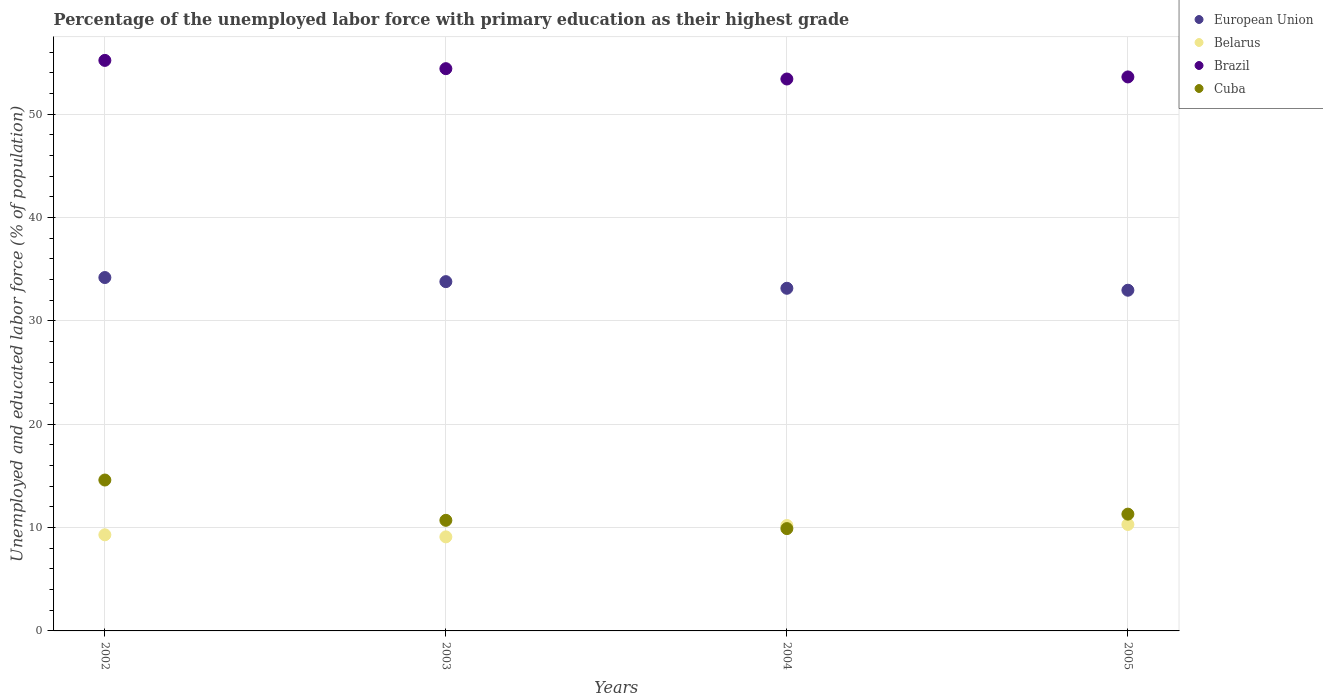What is the percentage of the unemployed labor force with primary education in Brazil in 2004?
Give a very brief answer. 53.4. Across all years, what is the maximum percentage of the unemployed labor force with primary education in Belarus?
Offer a terse response. 10.3. Across all years, what is the minimum percentage of the unemployed labor force with primary education in Belarus?
Make the answer very short. 9.1. In which year was the percentage of the unemployed labor force with primary education in European Union maximum?
Keep it short and to the point. 2002. What is the total percentage of the unemployed labor force with primary education in Cuba in the graph?
Provide a succinct answer. 46.5. What is the difference between the percentage of the unemployed labor force with primary education in European Union in 2002 and that in 2003?
Your response must be concise. 0.4. What is the difference between the percentage of the unemployed labor force with primary education in Belarus in 2002 and the percentage of the unemployed labor force with primary education in European Union in 2005?
Keep it short and to the point. -23.66. What is the average percentage of the unemployed labor force with primary education in Brazil per year?
Your answer should be very brief. 54.15. In the year 2005, what is the difference between the percentage of the unemployed labor force with primary education in Brazil and percentage of the unemployed labor force with primary education in Cuba?
Your response must be concise. 42.3. What is the ratio of the percentage of the unemployed labor force with primary education in Brazil in 2002 to that in 2004?
Provide a short and direct response. 1.03. Is the difference between the percentage of the unemployed labor force with primary education in Brazil in 2003 and 2004 greater than the difference between the percentage of the unemployed labor force with primary education in Cuba in 2003 and 2004?
Offer a very short reply. Yes. What is the difference between the highest and the second highest percentage of the unemployed labor force with primary education in Brazil?
Provide a succinct answer. 0.8. What is the difference between the highest and the lowest percentage of the unemployed labor force with primary education in Cuba?
Your answer should be compact. 4.7. Is the sum of the percentage of the unemployed labor force with primary education in Cuba in 2002 and 2005 greater than the maximum percentage of the unemployed labor force with primary education in Belarus across all years?
Provide a succinct answer. Yes. Is it the case that in every year, the sum of the percentage of the unemployed labor force with primary education in European Union and percentage of the unemployed labor force with primary education in Belarus  is greater than the percentage of the unemployed labor force with primary education in Cuba?
Provide a succinct answer. Yes. Is the percentage of the unemployed labor force with primary education in Belarus strictly greater than the percentage of the unemployed labor force with primary education in Brazil over the years?
Make the answer very short. No. How many years are there in the graph?
Ensure brevity in your answer.  4. What is the difference between two consecutive major ticks on the Y-axis?
Offer a very short reply. 10. How many legend labels are there?
Offer a terse response. 4. What is the title of the graph?
Provide a short and direct response. Percentage of the unemployed labor force with primary education as their highest grade. Does "Panama" appear as one of the legend labels in the graph?
Provide a short and direct response. No. What is the label or title of the X-axis?
Your answer should be very brief. Years. What is the label or title of the Y-axis?
Ensure brevity in your answer.  Unemployed and educated labor force (% of population). What is the Unemployed and educated labor force (% of population) of European Union in 2002?
Ensure brevity in your answer.  34.19. What is the Unemployed and educated labor force (% of population) in Belarus in 2002?
Provide a succinct answer. 9.3. What is the Unemployed and educated labor force (% of population) of Brazil in 2002?
Provide a short and direct response. 55.2. What is the Unemployed and educated labor force (% of population) in Cuba in 2002?
Give a very brief answer. 14.6. What is the Unemployed and educated labor force (% of population) in European Union in 2003?
Your answer should be very brief. 33.79. What is the Unemployed and educated labor force (% of population) in Belarus in 2003?
Your answer should be very brief. 9.1. What is the Unemployed and educated labor force (% of population) in Brazil in 2003?
Your response must be concise. 54.4. What is the Unemployed and educated labor force (% of population) in Cuba in 2003?
Offer a very short reply. 10.7. What is the Unemployed and educated labor force (% of population) in European Union in 2004?
Provide a short and direct response. 33.15. What is the Unemployed and educated labor force (% of population) of Belarus in 2004?
Make the answer very short. 10.2. What is the Unemployed and educated labor force (% of population) of Brazil in 2004?
Ensure brevity in your answer.  53.4. What is the Unemployed and educated labor force (% of population) in Cuba in 2004?
Make the answer very short. 9.9. What is the Unemployed and educated labor force (% of population) of European Union in 2005?
Give a very brief answer. 32.96. What is the Unemployed and educated labor force (% of population) in Belarus in 2005?
Your answer should be very brief. 10.3. What is the Unemployed and educated labor force (% of population) of Brazil in 2005?
Ensure brevity in your answer.  53.6. What is the Unemployed and educated labor force (% of population) of Cuba in 2005?
Offer a terse response. 11.3. Across all years, what is the maximum Unemployed and educated labor force (% of population) in European Union?
Your answer should be very brief. 34.19. Across all years, what is the maximum Unemployed and educated labor force (% of population) in Belarus?
Offer a very short reply. 10.3. Across all years, what is the maximum Unemployed and educated labor force (% of population) in Brazil?
Your answer should be compact. 55.2. Across all years, what is the maximum Unemployed and educated labor force (% of population) of Cuba?
Ensure brevity in your answer.  14.6. Across all years, what is the minimum Unemployed and educated labor force (% of population) of European Union?
Your answer should be very brief. 32.96. Across all years, what is the minimum Unemployed and educated labor force (% of population) of Belarus?
Your response must be concise. 9.1. Across all years, what is the minimum Unemployed and educated labor force (% of population) in Brazil?
Your response must be concise. 53.4. Across all years, what is the minimum Unemployed and educated labor force (% of population) of Cuba?
Keep it short and to the point. 9.9. What is the total Unemployed and educated labor force (% of population) of European Union in the graph?
Your answer should be compact. 134.1. What is the total Unemployed and educated labor force (% of population) of Belarus in the graph?
Keep it short and to the point. 38.9. What is the total Unemployed and educated labor force (% of population) in Brazil in the graph?
Keep it short and to the point. 216.6. What is the total Unemployed and educated labor force (% of population) of Cuba in the graph?
Provide a short and direct response. 46.5. What is the difference between the Unemployed and educated labor force (% of population) in European Union in 2002 and that in 2003?
Provide a short and direct response. 0.4. What is the difference between the Unemployed and educated labor force (% of population) of Brazil in 2002 and that in 2003?
Provide a succinct answer. 0.8. What is the difference between the Unemployed and educated labor force (% of population) in Cuba in 2002 and that in 2003?
Give a very brief answer. 3.9. What is the difference between the Unemployed and educated labor force (% of population) in European Union in 2002 and that in 2004?
Offer a very short reply. 1.04. What is the difference between the Unemployed and educated labor force (% of population) of Cuba in 2002 and that in 2004?
Give a very brief answer. 4.7. What is the difference between the Unemployed and educated labor force (% of population) in European Union in 2002 and that in 2005?
Provide a short and direct response. 1.23. What is the difference between the Unemployed and educated labor force (% of population) in Brazil in 2002 and that in 2005?
Offer a very short reply. 1.6. What is the difference between the Unemployed and educated labor force (% of population) of European Union in 2003 and that in 2004?
Give a very brief answer. 0.64. What is the difference between the Unemployed and educated labor force (% of population) in Belarus in 2003 and that in 2004?
Ensure brevity in your answer.  -1.1. What is the difference between the Unemployed and educated labor force (% of population) of Brazil in 2003 and that in 2004?
Give a very brief answer. 1. What is the difference between the Unemployed and educated labor force (% of population) of Cuba in 2003 and that in 2004?
Your answer should be compact. 0.8. What is the difference between the Unemployed and educated labor force (% of population) in European Union in 2003 and that in 2005?
Offer a very short reply. 0.83. What is the difference between the Unemployed and educated labor force (% of population) in Cuba in 2003 and that in 2005?
Your answer should be very brief. -0.6. What is the difference between the Unemployed and educated labor force (% of population) in European Union in 2004 and that in 2005?
Provide a succinct answer. 0.19. What is the difference between the Unemployed and educated labor force (% of population) in Belarus in 2004 and that in 2005?
Your answer should be very brief. -0.1. What is the difference between the Unemployed and educated labor force (% of population) of Brazil in 2004 and that in 2005?
Your answer should be very brief. -0.2. What is the difference between the Unemployed and educated labor force (% of population) of Cuba in 2004 and that in 2005?
Your answer should be very brief. -1.4. What is the difference between the Unemployed and educated labor force (% of population) of European Union in 2002 and the Unemployed and educated labor force (% of population) of Belarus in 2003?
Offer a terse response. 25.09. What is the difference between the Unemployed and educated labor force (% of population) in European Union in 2002 and the Unemployed and educated labor force (% of population) in Brazil in 2003?
Provide a succinct answer. -20.21. What is the difference between the Unemployed and educated labor force (% of population) of European Union in 2002 and the Unemployed and educated labor force (% of population) of Cuba in 2003?
Your response must be concise. 23.49. What is the difference between the Unemployed and educated labor force (% of population) of Belarus in 2002 and the Unemployed and educated labor force (% of population) of Brazil in 2003?
Your answer should be very brief. -45.1. What is the difference between the Unemployed and educated labor force (% of population) in Belarus in 2002 and the Unemployed and educated labor force (% of population) in Cuba in 2003?
Your answer should be very brief. -1.4. What is the difference between the Unemployed and educated labor force (% of population) of Brazil in 2002 and the Unemployed and educated labor force (% of population) of Cuba in 2003?
Your answer should be very brief. 44.5. What is the difference between the Unemployed and educated labor force (% of population) of European Union in 2002 and the Unemployed and educated labor force (% of population) of Belarus in 2004?
Your answer should be very brief. 23.99. What is the difference between the Unemployed and educated labor force (% of population) in European Union in 2002 and the Unemployed and educated labor force (% of population) in Brazil in 2004?
Ensure brevity in your answer.  -19.21. What is the difference between the Unemployed and educated labor force (% of population) in European Union in 2002 and the Unemployed and educated labor force (% of population) in Cuba in 2004?
Offer a very short reply. 24.29. What is the difference between the Unemployed and educated labor force (% of population) of Belarus in 2002 and the Unemployed and educated labor force (% of population) of Brazil in 2004?
Provide a succinct answer. -44.1. What is the difference between the Unemployed and educated labor force (% of population) of Brazil in 2002 and the Unemployed and educated labor force (% of population) of Cuba in 2004?
Provide a succinct answer. 45.3. What is the difference between the Unemployed and educated labor force (% of population) in European Union in 2002 and the Unemployed and educated labor force (% of population) in Belarus in 2005?
Offer a very short reply. 23.89. What is the difference between the Unemployed and educated labor force (% of population) of European Union in 2002 and the Unemployed and educated labor force (% of population) of Brazil in 2005?
Keep it short and to the point. -19.41. What is the difference between the Unemployed and educated labor force (% of population) in European Union in 2002 and the Unemployed and educated labor force (% of population) in Cuba in 2005?
Your response must be concise. 22.89. What is the difference between the Unemployed and educated labor force (% of population) of Belarus in 2002 and the Unemployed and educated labor force (% of population) of Brazil in 2005?
Provide a succinct answer. -44.3. What is the difference between the Unemployed and educated labor force (% of population) of Brazil in 2002 and the Unemployed and educated labor force (% of population) of Cuba in 2005?
Offer a terse response. 43.9. What is the difference between the Unemployed and educated labor force (% of population) in European Union in 2003 and the Unemployed and educated labor force (% of population) in Belarus in 2004?
Give a very brief answer. 23.59. What is the difference between the Unemployed and educated labor force (% of population) in European Union in 2003 and the Unemployed and educated labor force (% of population) in Brazil in 2004?
Make the answer very short. -19.61. What is the difference between the Unemployed and educated labor force (% of population) of European Union in 2003 and the Unemployed and educated labor force (% of population) of Cuba in 2004?
Make the answer very short. 23.89. What is the difference between the Unemployed and educated labor force (% of population) of Belarus in 2003 and the Unemployed and educated labor force (% of population) of Brazil in 2004?
Give a very brief answer. -44.3. What is the difference between the Unemployed and educated labor force (% of population) of Belarus in 2003 and the Unemployed and educated labor force (% of population) of Cuba in 2004?
Ensure brevity in your answer.  -0.8. What is the difference between the Unemployed and educated labor force (% of population) of Brazil in 2003 and the Unemployed and educated labor force (% of population) of Cuba in 2004?
Your answer should be very brief. 44.5. What is the difference between the Unemployed and educated labor force (% of population) of European Union in 2003 and the Unemployed and educated labor force (% of population) of Belarus in 2005?
Keep it short and to the point. 23.49. What is the difference between the Unemployed and educated labor force (% of population) in European Union in 2003 and the Unemployed and educated labor force (% of population) in Brazil in 2005?
Keep it short and to the point. -19.81. What is the difference between the Unemployed and educated labor force (% of population) of European Union in 2003 and the Unemployed and educated labor force (% of population) of Cuba in 2005?
Offer a very short reply. 22.49. What is the difference between the Unemployed and educated labor force (% of population) in Belarus in 2003 and the Unemployed and educated labor force (% of population) in Brazil in 2005?
Make the answer very short. -44.5. What is the difference between the Unemployed and educated labor force (% of population) in Brazil in 2003 and the Unemployed and educated labor force (% of population) in Cuba in 2005?
Your answer should be compact. 43.1. What is the difference between the Unemployed and educated labor force (% of population) in European Union in 2004 and the Unemployed and educated labor force (% of population) in Belarus in 2005?
Your answer should be compact. 22.85. What is the difference between the Unemployed and educated labor force (% of population) of European Union in 2004 and the Unemployed and educated labor force (% of population) of Brazil in 2005?
Make the answer very short. -20.45. What is the difference between the Unemployed and educated labor force (% of population) of European Union in 2004 and the Unemployed and educated labor force (% of population) of Cuba in 2005?
Provide a succinct answer. 21.85. What is the difference between the Unemployed and educated labor force (% of population) in Belarus in 2004 and the Unemployed and educated labor force (% of population) in Brazil in 2005?
Give a very brief answer. -43.4. What is the difference between the Unemployed and educated labor force (% of population) in Brazil in 2004 and the Unemployed and educated labor force (% of population) in Cuba in 2005?
Keep it short and to the point. 42.1. What is the average Unemployed and educated labor force (% of population) of European Union per year?
Provide a succinct answer. 33.53. What is the average Unemployed and educated labor force (% of population) of Belarus per year?
Keep it short and to the point. 9.72. What is the average Unemployed and educated labor force (% of population) in Brazil per year?
Make the answer very short. 54.15. What is the average Unemployed and educated labor force (% of population) of Cuba per year?
Offer a terse response. 11.62. In the year 2002, what is the difference between the Unemployed and educated labor force (% of population) of European Union and Unemployed and educated labor force (% of population) of Belarus?
Offer a very short reply. 24.89. In the year 2002, what is the difference between the Unemployed and educated labor force (% of population) of European Union and Unemployed and educated labor force (% of population) of Brazil?
Ensure brevity in your answer.  -21.01. In the year 2002, what is the difference between the Unemployed and educated labor force (% of population) of European Union and Unemployed and educated labor force (% of population) of Cuba?
Provide a succinct answer. 19.59. In the year 2002, what is the difference between the Unemployed and educated labor force (% of population) of Belarus and Unemployed and educated labor force (% of population) of Brazil?
Your answer should be very brief. -45.9. In the year 2002, what is the difference between the Unemployed and educated labor force (% of population) of Belarus and Unemployed and educated labor force (% of population) of Cuba?
Offer a terse response. -5.3. In the year 2002, what is the difference between the Unemployed and educated labor force (% of population) in Brazil and Unemployed and educated labor force (% of population) in Cuba?
Offer a very short reply. 40.6. In the year 2003, what is the difference between the Unemployed and educated labor force (% of population) of European Union and Unemployed and educated labor force (% of population) of Belarus?
Make the answer very short. 24.69. In the year 2003, what is the difference between the Unemployed and educated labor force (% of population) in European Union and Unemployed and educated labor force (% of population) in Brazil?
Your answer should be compact. -20.61. In the year 2003, what is the difference between the Unemployed and educated labor force (% of population) in European Union and Unemployed and educated labor force (% of population) in Cuba?
Offer a terse response. 23.09. In the year 2003, what is the difference between the Unemployed and educated labor force (% of population) of Belarus and Unemployed and educated labor force (% of population) of Brazil?
Your answer should be compact. -45.3. In the year 2003, what is the difference between the Unemployed and educated labor force (% of population) in Brazil and Unemployed and educated labor force (% of population) in Cuba?
Give a very brief answer. 43.7. In the year 2004, what is the difference between the Unemployed and educated labor force (% of population) in European Union and Unemployed and educated labor force (% of population) in Belarus?
Make the answer very short. 22.95. In the year 2004, what is the difference between the Unemployed and educated labor force (% of population) of European Union and Unemployed and educated labor force (% of population) of Brazil?
Ensure brevity in your answer.  -20.25. In the year 2004, what is the difference between the Unemployed and educated labor force (% of population) in European Union and Unemployed and educated labor force (% of population) in Cuba?
Ensure brevity in your answer.  23.25. In the year 2004, what is the difference between the Unemployed and educated labor force (% of population) of Belarus and Unemployed and educated labor force (% of population) of Brazil?
Ensure brevity in your answer.  -43.2. In the year 2004, what is the difference between the Unemployed and educated labor force (% of population) of Belarus and Unemployed and educated labor force (% of population) of Cuba?
Keep it short and to the point. 0.3. In the year 2004, what is the difference between the Unemployed and educated labor force (% of population) of Brazil and Unemployed and educated labor force (% of population) of Cuba?
Provide a short and direct response. 43.5. In the year 2005, what is the difference between the Unemployed and educated labor force (% of population) in European Union and Unemployed and educated labor force (% of population) in Belarus?
Provide a short and direct response. 22.66. In the year 2005, what is the difference between the Unemployed and educated labor force (% of population) of European Union and Unemployed and educated labor force (% of population) of Brazil?
Give a very brief answer. -20.64. In the year 2005, what is the difference between the Unemployed and educated labor force (% of population) of European Union and Unemployed and educated labor force (% of population) of Cuba?
Your answer should be very brief. 21.66. In the year 2005, what is the difference between the Unemployed and educated labor force (% of population) of Belarus and Unemployed and educated labor force (% of population) of Brazil?
Provide a succinct answer. -43.3. In the year 2005, what is the difference between the Unemployed and educated labor force (% of population) of Belarus and Unemployed and educated labor force (% of population) of Cuba?
Provide a succinct answer. -1. In the year 2005, what is the difference between the Unemployed and educated labor force (% of population) in Brazil and Unemployed and educated labor force (% of population) in Cuba?
Offer a very short reply. 42.3. What is the ratio of the Unemployed and educated labor force (% of population) in European Union in 2002 to that in 2003?
Your answer should be very brief. 1.01. What is the ratio of the Unemployed and educated labor force (% of population) in Belarus in 2002 to that in 2003?
Your answer should be very brief. 1.02. What is the ratio of the Unemployed and educated labor force (% of population) of Brazil in 2002 to that in 2003?
Your answer should be very brief. 1.01. What is the ratio of the Unemployed and educated labor force (% of population) in Cuba in 2002 to that in 2003?
Ensure brevity in your answer.  1.36. What is the ratio of the Unemployed and educated labor force (% of population) of European Union in 2002 to that in 2004?
Provide a short and direct response. 1.03. What is the ratio of the Unemployed and educated labor force (% of population) in Belarus in 2002 to that in 2004?
Give a very brief answer. 0.91. What is the ratio of the Unemployed and educated labor force (% of population) in Brazil in 2002 to that in 2004?
Your answer should be compact. 1.03. What is the ratio of the Unemployed and educated labor force (% of population) of Cuba in 2002 to that in 2004?
Offer a very short reply. 1.47. What is the ratio of the Unemployed and educated labor force (% of population) in European Union in 2002 to that in 2005?
Ensure brevity in your answer.  1.04. What is the ratio of the Unemployed and educated labor force (% of population) of Belarus in 2002 to that in 2005?
Keep it short and to the point. 0.9. What is the ratio of the Unemployed and educated labor force (% of population) in Brazil in 2002 to that in 2005?
Make the answer very short. 1.03. What is the ratio of the Unemployed and educated labor force (% of population) in Cuba in 2002 to that in 2005?
Your response must be concise. 1.29. What is the ratio of the Unemployed and educated labor force (% of population) of European Union in 2003 to that in 2004?
Ensure brevity in your answer.  1.02. What is the ratio of the Unemployed and educated labor force (% of population) of Belarus in 2003 to that in 2004?
Your answer should be very brief. 0.89. What is the ratio of the Unemployed and educated labor force (% of population) of Brazil in 2003 to that in 2004?
Your answer should be compact. 1.02. What is the ratio of the Unemployed and educated labor force (% of population) of Cuba in 2003 to that in 2004?
Keep it short and to the point. 1.08. What is the ratio of the Unemployed and educated labor force (% of population) in European Union in 2003 to that in 2005?
Provide a short and direct response. 1.03. What is the ratio of the Unemployed and educated labor force (% of population) in Belarus in 2003 to that in 2005?
Your response must be concise. 0.88. What is the ratio of the Unemployed and educated labor force (% of population) in Brazil in 2003 to that in 2005?
Offer a very short reply. 1.01. What is the ratio of the Unemployed and educated labor force (% of population) in Cuba in 2003 to that in 2005?
Provide a succinct answer. 0.95. What is the ratio of the Unemployed and educated labor force (% of population) of European Union in 2004 to that in 2005?
Your answer should be compact. 1.01. What is the ratio of the Unemployed and educated labor force (% of population) in Belarus in 2004 to that in 2005?
Your answer should be compact. 0.99. What is the ratio of the Unemployed and educated labor force (% of population) in Brazil in 2004 to that in 2005?
Provide a succinct answer. 1. What is the ratio of the Unemployed and educated labor force (% of population) of Cuba in 2004 to that in 2005?
Ensure brevity in your answer.  0.88. What is the difference between the highest and the second highest Unemployed and educated labor force (% of population) of European Union?
Keep it short and to the point. 0.4. What is the difference between the highest and the second highest Unemployed and educated labor force (% of population) of Belarus?
Make the answer very short. 0.1. What is the difference between the highest and the second highest Unemployed and educated labor force (% of population) in Brazil?
Give a very brief answer. 0.8. What is the difference between the highest and the second highest Unemployed and educated labor force (% of population) of Cuba?
Your answer should be very brief. 3.3. What is the difference between the highest and the lowest Unemployed and educated labor force (% of population) of European Union?
Keep it short and to the point. 1.23. 